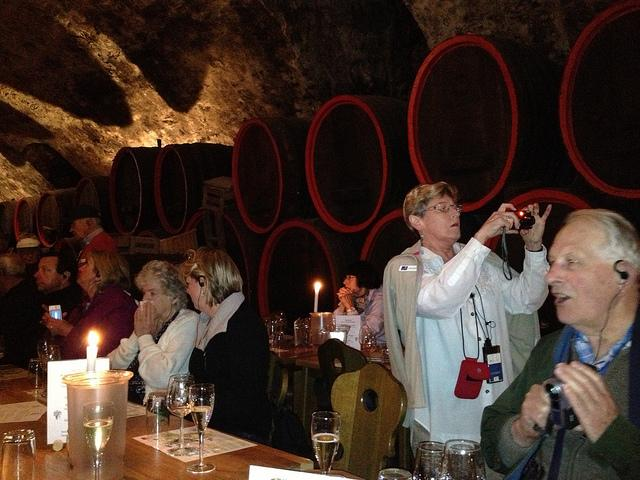What would most likely be stored in this type of location?

Choices:
A) alcohol
B) meat
C) furniture
D) produce alcohol 